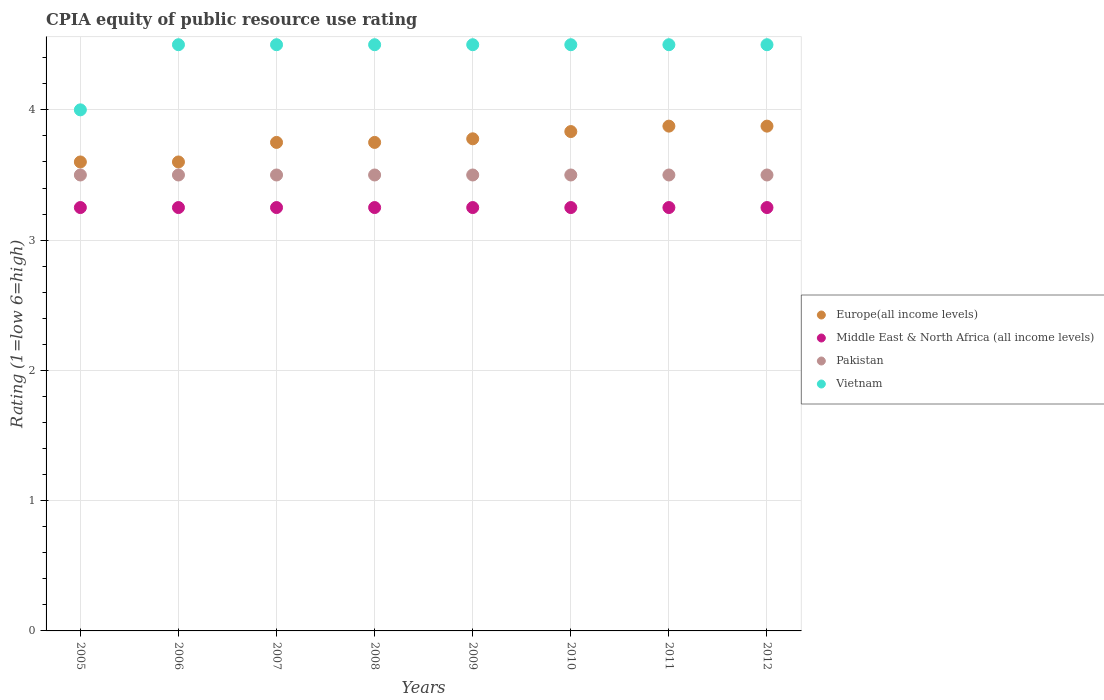How many different coloured dotlines are there?
Offer a very short reply. 4. Across all years, what is the maximum CPIA rating in Europe(all income levels)?
Keep it short and to the point. 3.88. What is the total CPIA rating in Middle East & North Africa (all income levels) in the graph?
Your answer should be compact. 26. What is the difference between the CPIA rating in Europe(all income levels) in 2006 and the CPIA rating in Middle East & North Africa (all income levels) in 2010?
Provide a short and direct response. 0.35. In the year 2012, what is the difference between the CPIA rating in Middle East & North Africa (all income levels) and CPIA rating in Vietnam?
Your answer should be very brief. -1.25. In how many years, is the CPIA rating in Europe(all income levels) greater than 1?
Your answer should be very brief. 8. Is the difference between the CPIA rating in Middle East & North Africa (all income levels) in 2006 and 2012 greater than the difference between the CPIA rating in Vietnam in 2006 and 2012?
Make the answer very short. No. What is the difference between the highest and the lowest CPIA rating in Pakistan?
Ensure brevity in your answer.  0. Is it the case that in every year, the sum of the CPIA rating in Middle East & North Africa (all income levels) and CPIA rating in Europe(all income levels)  is greater than the sum of CPIA rating in Pakistan and CPIA rating in Vietnam?
Offer a terse response. No. Is it the case that in every year, the sum of the CPIA rating in Europe(all income levels) and CPIA rating in Vietnam  is greater than the CPIA rating in Pakistan?
Offer a very short reply. Yes. Does the CPIA rating in Middle East & North Africa (all income levels) monotonically increase over the years?
Ensure brevity in your answer.  No. Is the CPIA rating in Europe(all income levels) strictly less than the CPIA rating in Middle East & North Africa (all income levels) over the years?
Give a very brief answer. No. How many dotlines are there?
Your answer should be compact. 4. Where does the legend appear in the graph?
Your answer should be compact. Center right. How are the legend labels stacked?
Offer a terse response. Vertical. What is the title of the graph?
Your response must be concise. CPIA equity of public resource use rating. What is the label or title of the X-axis?
Offer a terse response. Years. What is the label or title of the Y-axis?
Give a very brief answer. Rating (1=low 6=high). What is the Rating (1=low 6=high) in Europe(all income levels) in 2005?
Make the answer very short. 3.6. What is the Rating (1=low 6=high) of Pakistan in 2005?
Ensure brevity in your answer.  3.5. What is the Rating (1=low 6=high) of Europe(all income levels) in 2006?
Your response must be concise. 3.6. What is the Rating (1=low 6=high) of Middle East & North Africa (all income levels) in 2006?
Your answer should be compact. 3.25. What is the Rating (1=low 6=high) of Vietnam in 2006?
Make the answer very short. 4.5. What is the Rating (1=low 6=high) of Europe(all income levels) in 2007?
Provide a short and direct response. 3.75. What is the Rating (1=low 6=high) in Middle East & North Africa (all income levels) in 2007?
Your response must be concise. 3.25. What is the Rating (1=low 6=high) of Pakistan in 2007?
Make the answer very short. 3.5. What is the Rating (1=low 6=high) in Europe(all income levels) in 2008?
Your response must be concise. 3.75. What is the Rating (1=low 6=high) of Vietnam in 2008?
Make the answer very short. 4.5. What is the Rating (1=low 6=high) of Europe(all income levels) in 2009?
Your response must be concise. 3.78. What is the Rating (1=low 6=high) in Middle East & North Africa (all income levels) in 2009?
Give a very brief answer. 3.25. What is the Rating (1=low 6=high) in Europe(all income levels) in 2010?
Make the answer very short. 3.83. What is the Rating (1=low 6=high) of Middle East & North Africa (all income levels) in 2010?
Your response must be concise. 3.25. What is the Rating (1=low 6=high) of Pakistan in 2010?
Your answer should be very brief. 3.5. What is the Rating (1=low 6=high) of Europe(all income levels) in 2011?
Give a very brief answer. 3.88. What is the Rating (1=low 6=high) in Middle East & North Africa (all income levels) in 2011?
Keep it short and to the point. 3.25. What is the Rating (1=low 6=high) in Pakistan in 2011?
Your answer should be compact. 3.5. What is the Rating (1=low 6=high) in Europe(all income levels) in 2012?
Give a very brief answer. 3.88. Across all years, what is the maximum Rating (1=low 6=high) of Europe(all income levels)?
Your response must be concise. 3.88. Across all years, what is the maximum Rating (1=low 6=high) in Middle East & North Africa (all income levels)?
Your answer should be compact. 3.25. Across all years, what is the minimum Rating (1=low 6=high) in Europe(all income levels)?
Ensure brevity in your answer.  3.6. Across all years, what is the minimum Rating (1=low 6=high) in Middle East & North Africa (all income levels)?
Offer a terse response. 3.25. What is the total Rating (1=low 6=high) of Europe(all income levels) in the graph?
Give a very brief answer. 30.06. What is the total Rating (1=low 6=high) of Middle East & North Africa (all income levels) in the graph?
Offer a terse response. 26. What is the total Rating (1=low 6=high) of Vietnam in the graph?
Offer a very short reply. 35.5. What is the difference between the Rating (1=low 6=high) in Europe(all income levels) in 2005 and that in 2006?
Offer a terse response. 0. What is the difference between the Rating (1=low 6=high) in Middle East & North Africa (all income levels) in 2005 and that in 2006?
Offer a terse response. 0. What is the difference between the Rating (1=low 6=high) in Vietnam in 2005 and that in 2006?
Ensure brevity in your answer.  -0.5. What is the difference between the Rating (1=low 6=high) in Europe(all income levels) in 2005 and that in 2007?
Offer a terse response. -0.15. What is the difference between the Rating (1=low 6=high) in Vietnam in 2005 and that in 2007?
Your response must be concise. -0.5. What is the difference between the Rating (1=low 6=high) in Europe(all income levels) in 2005 and that in 2008?
Provide a succinct answer. -0.15. What is the difference between the Rating (1=low 6=high) in Middle East & North Africa (all income levels) in 2005 and that in 2008?
Provide a succinct answer. 0. What is the difference between the Rating (1=low 6=high) in Vietnam in 2005 and that in 2008?
Provide a succinct answer. -0.5. What is the difference between the Rating (1=low 6=high) of Europe(all income levels) in 2005 and that in 2009?
Your response must be concise. -0.18. What is the difference between the Rating (1=low 6=high) in Vietnam in 2005 and that in 2009?
Offer a terse response. -0.5. What is the difference between the Rating (1=low 6=high) in Europe(all income levels) in 2005 and that in 2010?
Offer a very short reply. -0.23. What is the difference between the Rating (1=low 6=high) in Middle East & North Africa (all income levels) in 2005 and that in 2010?
Provide a succinct answer. 0. What is the difference between the Rating (1=low 6=high) in Vietnam in 2005 and that in 2010?
Your answer should be compact. -0.5. What is the difference between the Rating (1=low 6=high) of Europe(all income levels) in 2005 and that in 2011?
Make the answer very short. -0.28. What is the difference between the Rating (1=low 6=high) of Middle East & North Africa (all income levels) in 2005 and that in 2011?
Offer a very short reply. 0. What is the difference between the Rating (1=low 6=high) of Europe(all income levels) in 2005 and that in 2012?
Provide a succinct answer. -0.28. What is the difference between the Rating (1=low 6=high) in Middle East & North Africa (all income levels) in 2005 and that in 2012?
Give a very brief answer. 0. What is the difference between the Rating (1=low 6=high) of Pakistan in 2005 and that in 2012?
Make the answer very short. 0. What is the difference between the Rating (1=low 6=high) of Vietnam in 2005 and that in 2012?
Provide a short and direct response. -0.5. What is the difference between the Rating (1=low 6=high) of Middle East & North Africa (all income levels) in 2006 and that in 2007?
Your answer should be very brief. 0. What is the difference between the Rating (1=low 6=high) of Europe(all income levels) in 2006 and that in 2008?
Your answer should be compact. -0.15. What is the difference between the Rating (1=low 6=high) in Middle East & North Africa (all income levels) in 2006 and that in 2008?
Provide a succinct answer. 0. What is the difference between the Rating (1=low 6=high) in Pakistan in 2006 and that in 2008?
Provide a short and direct response. 0. What is the difference between the Rating (1=low 6=high) in Europe(all income levels) in 2006 and that in 2009?
Your answer should be very brief. -0.18. What is the difference between the Rating (1=low 6=high) of Pakistan in 2006 and that in 2009?
Offer a terse response. 0. What is the difference between the Rating (1=low 6=high) of Vietnam in 2006 and that in 2009?
Offer a terse response. 0. What is the difference between the Rating (1=low 6=high) in Europe(all income levels) in 2006 and that in 2010?
Keep it short and to the point. -0.23. What is the difference between the Rating (1=low 6=high) of Pakistan in 2006 and that in 2010?
Offer a very short reply. 0. What is the difference between the Rating (1=low 6=high) in Vietnam in 2006 and that in 2010?
Make the answer very short. 0. What is the difference between the Rating (1=low 6=high) in Europe(all income levels) in 2006 and that in 2011?
Give a very brief answer. -0.28. What is the difference between the Rating (1=low 6=high) in Middle East & North Africa (all income levels) in 2006 and that in 2011?
Provide a short and direct response. 0. What is the difference between the Rating (1=low 6=high) of Pakistan in 2006 and that in 2011?
Make the answer very short. 0. What is the difference between the Rating (1=low 6=high) in Europe(all income levels) in 2006 and that in 2012?
Your answer should be very brief. -0.28. What is the difference between the Rating (1=low 6=high) in Europe(all income levels) in 2007 and that in 2008?
Your answer should be very brief. 0. What is the difference between the Rating (1=low 6=high) of Middle East & North Africa (all income levels) in 2007 and that in 2008?
Ensure brevity in your answer.  0. What is the difference between the Rating (1=low 6=high) in Vietnam in 2007 and that in 2008?
Provide a succinct answer. 0. What is the difference between the Rating (1=low 6=high) in Europe(all income levels) in 2007 and that in 2009?
Your response must be concise. -0.03. What is the difference between the Rating (1=low 6=high) in Middle East & North Africa (all income levels) in 2007 and that in 2009?
Give a very brief answer. 0. What is the difference between the Rating (1=low 6=high) of Pakistan in 2007 and that in 2009?
Ensure brevity in your answer.  0. What is the difference between the Rating (1=low 6=high) of Europe(all income levels) in 2007 and that in 2010?
Your response must be concise. -0.08. What is the difference between the Rating (1=low 6=high) in Pakistan in 2007 and that in 2010?
Your response must be concise. 0. What is the difference between the Rating (1=low 6=high) of Vietnam in 2007 and that in 2010?
Provide a succinct answer. 0. What is the difference between the Rating (1=low 6=high) in Europe(all income levels) in 2007 and that in 2011?
Make the answer very short. -0.12. What is the difference between the Rating (1=low 6=high) of Vietnam in 2007 and that in 2011?
Your answer should be very brief. 0. What is the difference between the Rating (1=low 6=high) of Europe(all income levels) in 2007 and that in 2012?
Your response must be concise. -0.12. What is the difference between the Rating (1=low 6=high) in Vietnam in 2007 and that in 2012?
Your answer should be very brief. 0. What is the difference between the Rating (1=low 6=high) in Europe(all income levels) in 2008 and that in 2009?
Provide a succinct answer. -0.03. What is the difference between the Rating (1=low 6=high) in Middle East & North Africa (all income levels) in 2008 and that in 2009?
Your answer should be very brief. 0. What is the difference between the Rating (1=low 6=high) of Europe(all income levels) in 2008 and that in 2010?
Your response must be concise. -0.08. What is the difference between the Rating (1=low 6=high) of Europe(all income levels) in 2008 and that in 2011?
Provide a succinct answer. -0.12. What is the difference between the Rating (1=low 6=high) of Middle East & North Africa (all income levels) in 2008 and that in 2011?
Provide a succinct answer. 0. What is the difference between the Rating (1=low 6=high) in Vietnam in 2008 and that in 2011?
Provide a short and direct response. 0. What is the difference between the Rating (1=low 6=high) in Europe(all income levels) in 2008 and that in 2012?
Ensure brevity in your answer.  -0.12. What is the difference between the Rating (1=low 6=high) in Europe(all income levels) in 2009 and that in 2010?
Your response must be concise. -0.06. What is the difference between the Rating (1=low 6=high) in Middle East & North Africa (all income levels) in 2009 and that in 2010?
Offer a terse response. 0. What is the difference between the Rating (1=low 6=high) of Vietnam in 2009 and that in 2010?
Offer a very short reply. 0. What is the difference between the Rating (1=low 6=high) in Europe(all income levels) in 2009 and that in 2011?
Make the answer very short. -0.1. What is the difference between the Rating (1=low 6=high) in Middle East & North Africa (all income levels) in 2009 and that in 2011?
Ensure brevity in your answer.  0. What is the difference between the Rating (1=low 6=high) of Pakistan in 2009 and that in 2011?
Give a very brief answer. 0. What is the difference between the Rating (1=low 6=high) of Vietnam in 2009 and that in 2011?
Keep it short and to the point. 0. What is the difference between the Rating (1=low 6=high) in Europe(all income levels) in 2009 and that in 2012?
Provide a succinct answer. -0.1. What is the difference between the Rating (1=low 6=high) in Middle East & North Africa (all income levels) in 2009 and that in 2012?
Your response must be concise. 0. What is the difference between the Rating (1=low 6=high) of Pakistan in 2009 and that in 2012?
Your answer should be very brief. 0. What is the difference between the Rating (1=low 6=high) of Europe(all income levels) in 2010 and that in 2011?
Provide a succinct answer. -0.04. What is the difference between the Rating (1=low 6=high) in Middle East & North Africa (all income levels) in 2010 and that in 2011?
Give a very brief answer. 0. What is the difference between the Rating (1=low 6=high) in Europe(all income levels) in 2010 and that in 2012?
Your response must be concise. -0.04. What is the difference between the Rating (1=low 6=high) of Middle East & North Africa (all income levels) in 2010 and that in 2012?
Make the answer very short. 0. What is the difference between the Rating (1=low 6=high) in Pakistan in 2010 and that in 2012?
Provide a short and direct response. 0. What is the difference between the Rating (1=low 6=high) in Vietnam in 2010 and that in 2012?
Your answer should be very brief. 0. What is the difference between the Rating (1=low 6=high) in Vietnam in 2011 and that in 2012?
Give a very brief answer. 0. What is the difference between the Rating (1=low 6=high) in Europe(all income levels) in 2005 and the Rating (1=low 6=high) in Vietnam in 2006?
Your response must be concise. -0.9. What is the difference between the Rating (1=low 6=high) in Middle East & North Africa (all income levels) in 2005 and the Rating (1=low 6=high) in Vietnam in 2006?
Keep it short and to the point. -1.25. What is the difference between the Rating (1=low 6=high) in Pakistan in 2005 and the Rating (1=low 6=high) in Vietnam in 2006?
Your answer should be very brief. -1. What is the difference between the Rating (1=low 6=high) in Europe(all income levels) in 2005 and the Rating (1=low 6=high) in Middle East & North Africa (all income levels) in 2007?
Ensure brevity in your answer.  0.35. What is the difference between the Rating (1=low 6=high) in Europe(all income levels) in 2005 and the Rating (1=low 6=high) in Pakistan in 2007?
Your answer should be compact. 0.1. What is the difference between the Rating (1=low 6=high) of Middle East & North Africa (all income levels) in 2005 and the Rating (1=low 6=high) of Vietnam in 2007?
Make the answer very short. -1.25. What is the difference between the Rating (1=low 6=high) in Europe(all income levels) in 2005 and the Rating (1=low 6=high) in Vietnam in 2008?
Offer a terse response. -0.9. What is the difference between the Rating (1=low 6=high) of Middle East & North Africa (all income levels) in 2005 and the Rating (1=low 6=high) of Vietnam in 2008?
Your answer should be very brief. -1.25. What is the difference between the Rating (1=low 6=high) of Europe(all income levels) in 2005 and the Rating (1=low 6=high) of Middle East & North Africa (all income levels) in 2009?
Make the answer very short. 0.35. What is the difference between the Rating (1=low 6=high) in Europe(all income levels) in 2005 and the Rating (1=low 6=high) in Pakistan in 2009?
Offer a terse response. 0.1. What is the difference between the Rating (1=low 6=high) of Europe(all income levels) in 2005 and the Rating (1=low 6=high) of Vietnam in 2009?
Offer a terse response. -0.9. What is the difference between the Rating (1=low 6=high) of Middle East & North Africa (all income levels) in 2005 and the Rating (1=low 6=high) of Vietnam in 2009?
Give a very brief answer. -1.25. What is the difference between the Rating (1=low 6=high) in Europe(all income levels) in 2005 and the Rating (1=low 6=high) in Middle East & North Africa (all income levels) in 2010?
Make the answer very short. 0.35. What is the difference between the Rating (1=low 6=high) of Europe(all income levels) in 2005 and the Rating (1=low 6=high) of Pakistan in 2010?
Offer a very short reply. 0.1. What is the difference between the Rating (1=low 6=high) in Europe(all income levels) in 2005 and the Rating (1=low 6=high) in Vietnam in 2010?
Ensure brevity in your answer.  -0.9. What is the difference between the Rating (1=low 6=high) in Middle East & North Africa (all income levels) in 2005 and the Rating (1=low 6=high) in Vietnam in 2010?
Your answer should be compact. -1.25. What is the difference between the Rating (1=low 6=high) of Pakistan in 2005 and the Rating (1=low 6=high) of Vietnam in 2010?
Your response must be concise. -1. What is the difference between the Rating (1=low 6=high) in Europe(all income levels) in 2005 and the Rating (1=low 6=high) in Middle East & North Africa (all income levels) in 2011?
Keep it short and to the point. 0.35. What is the difference between the Rating (1=low 6=high) in Europe(all income levels) in 2005 and the Rating (1=low 6=high) in Pakistan in 2011?
Provide a succinct answer. 0.1. What is the difference between the Rating (1=low 6=high) in Middle East & North Africa (all income levels) in 2005 and the Rating (1=low 6=high) in Vietnam in 2011?
Keep it short and to the point. -1.25. What is the difference between the Rating (1=low 6=high) of Europe(all income levels) in 2005 and the Rating (1=low 6=high) of Middle East & North Africa (all income levels) in 2012?
Provide a short and direct response. 0.35. What is the difference between the Rating (1=low 6=high) of Europe(all income levels) in 2005 and the Rating (1=low 6=high) of Vietnam in 2012?
Your answer should be compact. -0.9. What is the difference between the Rating (1=low 6=high) in Middle East & North Africa (all income levels) in 2005 and the Rating (1=low 6=high) in Vietnam in 2012?
Your answer should be very brief. -1.25. What is the difference between the Rating (1=low 6=high) in Pakistan in 2005 and the Rating (1=low 6=high) in Vietnam in 2012?
Provide a short and direct response. -1. What is the difference between the Rating (1=low 6=high) in Europe(all income levels) in 2006 and the Rating (1=low 6=high) in Middle East & North Africa (all income levels) in 2007?
Provide a short and direct response. 0.35. What is the difference between the Rating (1=low 6=high) in Europe(all income levels) in 2006 and the Rating (1=low 6=high) in Vietnam in 2007?
Keep it short and to the point. -0.9. What is the difference between the Rating (1=low 6=high) in Middle East & North Africa (all income levels) in 2006 and the Rating (1=low 6=high) in Vietnam in 2007?
Your answer should be compact. -1.25. What is the difference between the Rating (1=low 6=high) of Europe(all income levels) in 2006 and the Rating (1=low 6=high) of Middle East & North Africa (all income levels) in 2008?
Provide a succinct answer. 0.35. What is the difference between the Rating (1=low 6=high) in Europe(all income levels) in 2006 and the Rating (1=low 6=high) in Vietnam in 2008?
Make the answer very short. -0.9. What is the difference between the Rating (1=low 6=high) of Middle East & North Africa (all income levels) in 2006 and the Rating (1=low 6=high) of Vietnam in 2008?
Your answer should be compact. -1.25. What is the difference between the Rating (1=low 6=high) in Europe(all income levels) in 2006 and the Rating (1=low 6=high) in Middle East & North Africa (all income levels) in 2009?
Your answer should be compact. 0.35. What is the difference between the Rating (1=low 6=high) of Europe(all income levels) in 2006 and the Rating (1=low 6=high) of Pakistan in 2009?
Offer a terse response. 0.1. What is the difference between the Rating (1=low 6=high) of Middle East & North Africa (all income levels) in 2006 and the Rating (1=low 6=high) of Vietnam in 2009?
Your answer should be very brief. -1.25. What is the difference between the Rating (1=low 6=high) in Europe(all income levels) in 2006 and the Rating (1=low 6=high) in Middle East & North Africa (all income levels) in 2010?
Offer a terse response. 0.35. What is the difference between the Rating (1=low 6=high) of Europe(all income levels) in 2006 and the Rating (1=low 6=high) of Vietnam in 2010?
Your answer should be compact. -0.9. What is the difference between the Rating (1=low 6=high) of Middle East & North Africa (all income levels) in 2006 and the Rating (1=low 6=high) of Vietnam in 2010?
Give a very brief answer. -1.25. What is the difference between the Rating (1=low 6=high) of Europe(all income levels) in 2006 and the Rating (1=low 6=high) of Pakistan in 2011?
Your response must be concise. 0.1. What is the difference between the Rating (1=low 6=high) of Europe(all income levels) in 2006 and the Rating (1=low 6=high) of Vietnam in 2011?
Provide a succinct answer. -0.9. What is the difference between the Rating (1=low 6=high) of Middle East & North Africa (all income levels) in 2006 and the Rating (1=low 6=high) of Pakistan in 2011?
Your answer should be compact. -0.25. What is the difference between the Rating (1=low 6=high) in Middle East & North Africa (all income levels) in 2006 and the Rating (1=low 6=high) in Vietnam in 2011?
Keep it short and to the point. -1.25. What is the difference between the Rating (1=low 6=high) in Pakistan in 2006 and the Rating (1=low 6=high) in Vietnam in 2011?
Your answer should be compact. -1. What is the difference between the Rating (1=low 6=high) of Europe(all income levels) in 2006 and the Rating (1=low 6=high) of Pakistan in 2012?
Give a very brief answer. 0.1. What is the difference between the Rating (1=low 6=high) in Europe(all income levels) in 2006 and the Rating (1=low 6=high) in Vietnam in 2012?
Offer a terse response. -0.9. What is the difference between the Rating (1=low 6=high) of Middle East & North Africa (all income levels) in 2006 and the Rating (1=low 6=high) of Pakistan in 2012?
Your answer should be very brief. -0.25. What is the difference between the Rating (1=low 6=high) of Middle East & North Africa (all income levels) in 2006 and the Rating (1=low 6=high) of Vietnam in 2012?
Provide a short and direct response. -1.25. What is the difference between the Rating (1=low 6=high) of Europe(all income levels) in 2007 and the Rating (1=low 6=high) of Vietnam in 2008?
Offer a very short reply. -0.75. What is the difference between the Rating (1=low 6=high) of Middle East & North Africa (all income levels) in 2007 and the Rating (1=low 6=high) of Pakistan in 2008?
Give a very brief answer. -0.25. What is the difference between the Rating (1=low 6=high) in Middle East & North Africa (all income levels) in 2007 and the Rating (1=low 6=high) in Vietnam in 2008?
Keep it short and to the point. -1.25. What is the difference between the Rating (1=low 6=high) in Europe(all income levels) in 2007 and the Rating (1=low 6=high) in Vietnam in 2009?
Make the answer very short. -0.75. What is the difference between the Rating (1=low 6=high) in Middle East & North Africa (all income levels) in 2007 and the Rating (1=low 6=high) in Pakistan in 2009?
Your response must be concise. -0.25. What is the difference between the Rating (1=low 6=high) of Middle East & North Africa (all income levels) in 2007 and the Rating (1=low 6=high) of Vietnam in 2009?
Your answer should be very brief. -1.25. What is the difference between the Rating (1=low 6=high) in Europe(all income levels) in 2007 and the Rating (1=low 6=high) in Middle East & North Africa (all income levels) in 2010?
Provide a short and direct response. 0.5. What is the difference between the Rating (1=low 6=high) in Europe(all income levels) in 2007 and the Rating (1=low 6=high) in Vietnam in 2010?
Make the answer very short. -0.75. What is the difference between the Rating (1=low 6=high) of Middle East & North Africa (all income levels) in 2007 and the Rating (1=low 6=high) of Pakistan in 2010?
Your answer should be very brief. -0.25. What is the difference between the Rating (1=low 6=high) in Middle East & North Africa (all income levels) in 2007 and the Rating (1=low 6=high) in Vietnam in 2010?
Provide a succinct answer. -1.25. What is the difference between the Rating (1=low 6=high) of Europe(all income levels) in 2007 and the Rating (1=low 6=high) of Pakistan in 2011?
Provide a succinct answer. 0.25. What is the difference between the Rating (1=low 6=high) in Europe(all income levels) in 2007 and the Rating (1=low 6=high) in Vietnam in 2011?
Make the answer very short. -0.75. What is the difference between the Rating (1=low 6=high) of Middle East & North Africa (all income levels) in 2007 and the Rating (1=low 6=high) of Pakistan in 2011?
Your answer should be compact. -0.25. What is the difference between the Rating (1=low 6=high) of Middle East & North Africa (all income levels) in 2007 and the Rating (1=low 6=high) of Vietnam in 2011?
Your answer should be compact. -1.25. What is the difference between the Rating (1=low 6=high) in Europe(all income levels) in 2007 and the Rating (1=low 6=high) in Pakistan in 2012?
Your response must be concise. 0.25. What is the difference between the Rating (1=low 6=high) of Europe(all income levels) in 2007 and the Rating (1=low 6=high) of Vietnam in 2012?
Provide a short and direct response. -0.75. What is the difference between the Rating (1=low 6=high) in Middle East & North Africa (all income levels) in 2007 and the Rating (1=low 6=high) in Vietnam in 2012?
Keep it short and to the point. -1.25. What is the difference between the Rating (1=low 6=high) in Europe(all income levels) in 2008 and the Rating (1=low 6=high) in Vietnam in 2009?
Make the answer very short. -0.75. What is the difference between the Rating (1=low 6=high) in Middle East & North Africa (all income levels) in 2008 and the Rating (1=low 6=high) in Vietnam in 2009?
Your response must be concise. -1.25. What is the difference between the Rating (1=low 6=high) in Pakistan in 2008 and the Rating (1=low 6=high) in Vietnam in 2009?
Provide a short and direct response. -1. What is the difference between the Rating (1=low 6=high) in Europe(all income levels) in 2008 and the Rating (1=low 6=high) in Middle East & North Africa (all income levels) in 2010?
Your answer should be very brief. 0.5. What is the difference between the Rating (1=low 6=high) of Europe(all income levels) in 2008 and the Rating (1=low 6=high) of Vietnam in 2010?
Provide a succinct answer. -0.75. What is the difference between the Rating (1=low 6=high) of Middle East & North Africa (all income levels) in 2008 and the Rating (1=low 6=high) of Vietnam in 2010?
Offer a terse response. -1.25. What is the difference between the Rating (1=low 6=high) in Pakistan in 2008 and the Rating (1=low 6=high) in Vietnam in 2010?
Offer a terse response. -1. What is the difference between the Rating (1=low 6=high) in Europe(all income levels) in 2008 and the Rating (1=low 6=high) in Middle East & North Africa (all income levels) in 2011?
Provide a short and direct response. 0.5. What is the difference between the Rating (1=low 6=high) in Europe(all income levels) in 2008 and the Rating (1=low 6=high) in Pakistan in 2011?
Offer a terse response. 0.25. What is the difference between the Rating (1=low 6=high) in Europe(all income levels) in 2008 and the Rating (1=low 6=high) in Vietnam in 2011?
Ensure brevity in your answer.  -0.75. What is the difference between the Rating (1=low 6=high) of Middle East & North Africa (all income levels) in 2008 and the Rating (1=low 6=high) of Pakistan in 2011?
Provide a succinct answer. -0.25. What is the difference between the Rating (1=low 6=high) in Middle East & North Africa (all income levels) in 2008 and the Rating (1=low 6=high) in Vietnam in 2011?
Make the answer very short. -1.25. What is the difference between the Rating (1=low 6=high) of Europe(all income levels) in 2008 and the Rating (1=low 6=high) of Vietnam in 2012?
Keep it short and to the point. -0.75. What is the difference between the Rating (1=low 6=high) of Middle East & North Africa (all income levels) in 2008 and the Rating (1=low 6=high) of Vietnam in 2012?
Give a very brief answer. -1.25. What is the difference between the Rating (1=low 6=high) in Europe(all income levels) in 2009 and the Rating (1=low 6=high) in Middle East & North Africa (all income levels) in 2010?
Ensure brevity in your answer.  0.53. What is the difference between the Rating (1=low 6=high) of Europe(all income levels) in 2009 and the Rating (1=low 6=high) of Pakistan in 2010?
Your answer should be compact. 0.28. What is the difference between the Rating (1=low 6=high) in Europe(all income levels) in 2009 and the Rating (1=low 6=high) in Vietnam in 2010?
Ensure brevity in your answer.  -0.72. What is the difference between the Rating (1=low 6=high) of Middle East & North Africa (all income levels) in 2009 and the Rating (1=low 6=high) of Vietnam in 2010?
Provide a short and direct response. -1.25. What is the difference between the Rating (1=low 6=high) of Pakistan in 2009 and the Rating (1=low 6=high) of Vietnam in 2010?
Provide a succinct answer. -1. What is the difference between the Rating (1=low 6=high) of Europe(all income levels) in 2009 and the Rating (1=low 6=high) of Middle East & North Africa (all income levels) in 2011?
Offer a very short reply. 0.53. What is the difference between the Rating (1=low 6=high) in Europe(all income levels) in 2009 and the Rating (1=low 6=high) in Pakistan in 2011?
Offer a very short reply. 0.28. What is the difference between the Rating (1=low 6=high) of Europe(all income levels) in 2009 and the Rating (1=low 6=high) of Vietnam in 2011?
Your response must be concise. -0.72. What is the difference between the Rating (1=low 6=high) in Middle East & North Africa (all income levels) in 2009 and the Rating (1=low 6=high) in Vietnam in 2011?
Give a very brief answer. -1.25. What is the difference between the Rating (1=low 6=high) in Europe(all income levels) in 2009 and the Rating (1=low 6=high) in Middle East & North Africa (all income levels) in 2012?
Keep it short and to the point. 0.53. What is the difference between the Rating (1=low 6=high) of Europe(all income levels) in 2009 and the Rating (1=low 6=high) of Pakistan in 2012?
Make the answer very short. 0.28. What is the difference between the Rating (1=low 6=high) in Europe(all income levels) in 2009 and the Rating (1=low 6=high) in Vietnam in 2012?
Ensure brevity in your answer.  -0.72. What is the difference between the Rating (1=low 6=high) in Middle East & North Africa (all income levels) in 2009 and the Rating (1=low 6=high) in Pakistan in 2012?
Provide a succinct answer. -0.25. What is the difference between the Rating (1=low 6=high) of Middle East & North Africa (all income levels) in 2009 and the Rating (1=low 6=high) of Vietnam in 2012?
Provide a succinct answer. -1.25. What is the difference between the Rating (1=low 6=high) of Pakistan in 2009 and the Rating (1=low 6=high) of Vietnam in 2012?
Ensure brevity in your answer.  -1. What is the difference between the Rating (1=low 6=high) of Europe(all income levels) in 2010 and the Rating (1=low 6=high) of Middle East & North Africa (all income levels) in 2011?
Your answer should be compact. 0.58. What is the difference between the Rating (1=low 6=high) in Europe(all income levels) in 2010 and the Rating (1=low 6=high) in Vietnam in 2011?
Your answer should be compact. -0.67. What is the difference between the Rating (1=low 6=high) of Middle East & North Africa (all income levels) in 2010 and the Rating (1=low 6=high) of Vietnam in 2011?
Your answer should be very brief. -1.25. What is the difference between the Rating (1=low 6=high) of Europe(all income levels) in 2010 and the Rating (1=low 6=high) of Middle East & North Africa (all income levels) in 2012?
Your answer should be very brief. 0.58. What is the difference between the Rating (1=low 6=high) of Europe(all income levels) in 2010 and the Rating (1=low 6=high) of Pakistan in 2012?
Ensure brevity in your answer.  0.33. What is the difference between the Rating (1=low 6=high) of Europe(all income levels) in 2010 and the Rating (1=low 6=high) of Vietnam in 2012?
Your response must be concise. -0.67. What is the difference between the Rating (1=low 6=high) of Middle East & North Africa (all income levels) in 2010 and the Rating (1=low 6=high) of Pakistan in 2012?
Provide a short and direct response. -0.25. What is the difference between the Rating (1=low 6=high) of Middle East & North Africa (all income levels) in 2010 and the Rating (1=low 6=high) of Vietnam in 2012?
Your answer should be compact. -1.25. What is the difference between the Rating (1=low 6=high) of Europe(all income levels) in 2011 and the Rating (1=low 6=high) of Middle East & North Africa (all income levels) in 2012?
Give a very brief answer. 0.62. What is the difference between the Rating (1=low 6=high) of Europe(all income levels) in 2011 and the Rating (1=low 6=high) of Pakistan in 2012?
Give a very brief answer. 0.38. What is the difference between the Rating (1=low 6=high) of Europe(all income levels) in 2011 and the Rating (1=low 6=high) of Vietnam in 2012?
Your answer should be compact. -0.62. What is the difference between the Rating (1=low 6=high) of Middle East & North Africa (all income levels) in 2011 and the Rating (1=low 6=high) of Pakistan in 2012?
Keep it short and to the point. -0.25. What is the difference between the Rating (1=low 6=high) in Middle East & North Africa (all income levels) in 2011 and the Rating (1=low 6=high) in Vietnam in 2012?
Keep it short and to the point. -1.25. What is the average Rating (1=low 6=high) in Europe(all income levels) per year?
Your answer should be compact. 3.76. What is the average Rating (1=low 6=high) in Pakistan per year?
Give a very brief answer. 3.5. What is the average Rating (1=low 6=high) of Vietnam per year?
Your answer should be very brief. 4.44. In the year 2005, what is the difference between the Rating (1=low 6=high) of Europe(all income levels) and Rating (1=low 6=high) of Vietnam?
Provide a short and direct response. -0.4. In the year 2005, what is the difference between the Rating (1=low 6=high) of Middle East & North Africa (all income levels) and Rating (1=low 6=high) of Vietnam?
Your answer should be very brief. -0.75. In the year 2005, what is the difference between the Rating (1=low 6=high) of Pakistan and Rating (1=low 6=high) of Vietnam?
Your response must be concise. -0.5. In the year 2006, what is the difference between the Rating (1=low 6=high) of Europe(all income levels) and Rating (1=low 6=high) of Vietnam?
Give a very brief answer. -0.9. In the year 2006, what is the difference between the Rating (1=low 6=high) in Middle East & North Africa (all income levels) and Rating (1=low 6=high) in Pakistan?
Provide a succinct answer. -0.25. In the year 2006, what is the difference between the Rating (1=low 6=high) in Middle East & North Africa (all income levels) and Rating (1=low 6=high) in Vietnam?
Your answer should be very brief. -1.25. In the year 2007, what is the difference between the Rating (1=low 6=high) of Europe(all income levels) and Rating (1=low 6=high) of Middle East & North Africa (all income levels)?
Make the answer very short. 0.5. In the year 2007, what is the difference between the Rating (1=low 6=high) of Europe(all income levels) and Rating (1=low 6=high) of Pakistan?
Provide a short and direct response. 0.25. In the year 2007, what is the difference between the Rating (1=low 6=high) of Europe(all income levels) and Rating (1=low 6=high) of Vietnam?
Ensure brevity in your answer.  -0.75. In the year 2007, what is the difference between the Rating (1=low 6=high) of Middle East & North Africa (all income levels) and Rating (1=low 6=high) of Vietnam?
Make the answer very short. -1.25. In the year 2008, what is the difference between the Rating (1=low 6=high) of Europe(all income levels) and Rating (1=low 6=high) of Pakistan?
Give a very brief answer. 0.25. In the year 2008, what is the difference between the Rating (1=low 6=high) in Europe(all income levels) and Rating (1=low 6=high) in Vietnam?
Make the answer very short. -0.75. In the year 2008, what is the difference between the Rating (1=low 6=high) of Middle East & North Africa (all income levels) and Rating (1=low 6=high) of Vietnam?
Provide a short and direct response. -1.25. In the year 2009, what is the difference between the Rating (1=low 6=high) in Europe(all income levels) and Rating (1=low 6=high) in Middle East & North Africa (all income levels)?
Keep it short and to the point. 0.53. In the year 2009, what is the difference between the Rating (1=low 6=high) in Europe(all income levels) and Rating (1=low 6=high) in Pakistan?
Offer a terse response. 0.28. In the year 2009, what is the difference between the Rating (1=low 6=high) of Europe(all income levels) and Rating (1=low 6=high) of Vietnam?
Make the answer very short. -0.72. In the year 2009, what is the difference between the Rating (1=low 6=high) of Middle East & North Africa (all income levels) and Rating (1=low 6=high) of Vietnam?
Offer a very short reply. -1.25. In the year 2010, what is the difference between the Rating (1=low 6=high) of Europe(all income levels) and Rating (1=low 6=high) of Middle East & North Africa (all income levels)?
Offer a terse response. 0.58. In the year 2010, what is the difference between the Rating (1=low 6=high) in Europe(all income levels) and Rating (1=low 6=high) in Vietnam?
Your response must be concise. -0.67. In the year 2010, what is the difference between the Rating (1=low 6=high) in Middle East & North Africa (all income levels) and Rating (1=low 6=high) in Pakistan?
Provide a short and direct response. -0.25. In the year 2010, what is the difference between the Rating (1=low 6=high) in Middle East & North Africa (all income levels) and Rating (1=low 6=high) in Vietnam?
Offer a very short reply. -1.25. In the year 2010, what is the difference between the Rating (1=low 6=high) of Pakistan and Rating (1=low 6=high) of Vietnam?
Offer a very short reply. -1. In the year 2011, what is the difference between the Rating (1=low 6=high) in Europe(all income levels) and Rating (1=low 6=high) in Vietnam?
Keep it short and to the point. -0.62. In the year 2011, what is the difference between the Rating (1=low 6=high) of Middle East & North Africa (all income levels) and Rating (1=low 6=high) of Vietnam?
Your answer should be very brief. -1.25. In the year 2012, what is the difference between the Rating (1=low 6=high) in Europe(all income levels) and Rating (1=low 6=high) in Pakistan?
Provide a short and direct response. 0.38. In the year 2012, what is the difference between the Rating (1=low 6=high) in Europe(all income levels) and Rating (1=low 6=high) in Vietnam?
Your response must be concise. -0.62. In the year 2012, what is the difference between the Rating (1=low 6=high) in Middle East & North Africa (all income levels) and Rating (1=low 6=high) in Vietnam?
Provide a succinct answer. -1.25. In the year 2012, what is the difference between the Rating (1=low 6=high) of Pakistan and Rating (1=low 6=high) of Vietnam?
Ensure brevity in your answer.  -1. What is the ratio of the Rating (1=low 6=high) of Middle East & North Africa (all income levels) in 2005 to that in 2006?
Keep it short and to the point. 1. What is the ratio of the Rating (1=low 6=high) in Middle East & North Africa (all income levels) in 2005 to that in 2007?
Offer a very short reply. 1. What is the ratio of the Rating (1=low 6=high) in Europe(all income levels) in 2005 to that in 2008?
Provide a succinct answer. 0.96. What is the ratio of the Rating (1=low 6=high) of Middle East & North Africa (all income levels) in 2005 to that in 2008?
Make the answer very short. 1. What is the ratio of the Rating (1=low 6=high) in Pakistan in 2005 to that in 2008?
Offer a very short reply. 1. What is the ratio of the Rating (1=low 6=high) of Europe(all income levels) in 2005 to that in 2009?
Offer a very short reply. 0.95. What is the ratio of the Rating (1=low 6=high) in Middle East & North Africa (all income levels) in 2005 to that in 2009?
Give a very brief answer. 1. What is the ratio of the Rating (1=low 6=high) of Pakistan in 2005 to that in 2009?
Ensure brevity in your answer.  1. What is the ratio of the Rating (1=low 6=high) of Europe(all income levels) in 2005 to that in 2010?
Offer a terse response. 0.94. What is the ratio of the Rating (1=low 6=high) of Vietnam in 2005 to that in 2010?
Offer a very short reply. 0.89. What is the ratio of the Rating (1=low 6=high) of Europe(all income levels) in 2005 to that in 2011?
Keep it short and to the point. 0.93. What is the ratio of the Rating (1=low 6=high) of Pakistan in 2005 to that in 2011?
Keep it short and to the point. 1. What is the ratio of the Rating (1=low 6=high) of Europe(all income levels) in 2005 to that in 2012?
Your response must be concise. 0.93. What is the ratio of the Rating (1=low 6=high) of Vietnam in 2005 to that in 2012?
Provide a short and direct response. 0.89. What is the ratio of the Rating (1=low 6=high) of Middle East & North Africa (all income levels) in 2006 to that in 2007?
Offer a terse response. 1. What is the ratio of the Rating (1=low 6=high) in Vietnam in 2006 to that in 2008?
Offer a very short reply. 1. What is the ratio of the Rating (1=low 6=high) of Europe(all income levels) in 2006 to that in 2009?
Make the answer very short. 0.95. What is the ratio of the Rating (1=low 6=high) of Middle East & North Africa (all income levels) in 2006 to that in 2009?
Offer a very short reply. 1. What is the ratio of the Rating (1=low 6=high) in Europe(all income levels) in 2006 to that in 2010?
Provide a succinct answer. 0.94. What is the ratio of the Rating (1=low 6=high) in Pakistan in 2006 to that in 2010?
Offer a very short reply. 1. What is the ratio of the Rating (1=low 6=high) of Europe(all income levels) in 2006 to that in 2011?
Your answer should be compact. 0.93. What is the ratio of the Rating (1=low 6=high) in Pakistan in 2006 to that in 2011?
Provide a short and direct response. 1. What is the ratio of the Rating (1=low 6=high) in Europe(all income levels) in 2006 to that in 2012?
Ensure brevity in your answer.  0.93. What is the ratio of the Rating (1=low 6=high) of Middle East & North Africa (all income levels) in 2006 to that in 2012?
Provide a succinct answer. 1. What is the ratio of the Rating (1=low 6=high) in Pakistan in 2006 to that in 2012?
Your response must be concise. 1. What is the ratio of the Rating (1=low 6=high) in Vietnam in 2006 to that in 2012?
Provide a short and direct response. 1. What is the ratio of the Rating (1=low 6=high) in Middle East & North Africa (all income levels) in 2007 to that in 2008?
Ensure brevity in your answer.  1. What is the ratio of the Rating (1=low 6=high) of Vietnam in 2007 to that in 2008?
Your answer should be compact. 1. What is the ratio of the Rating (1=low 6=high) in Europe(all income levels) in 2007 to that in 2010?
Keep it short and to the point. 0.98. What is the ratio of the Rating (1=low 6=high) of Pakistan in 2007 to that in 2010?
Give a very brief answer. 1. What is the ratio of the Rating (1=low 6=high) of Europe(all income levels) in 2007 to that in 2011?
Provide a short and direct response. 0.97. What is the ratio of the Rating (1=low 6=high) of Middle East & North Africa (all income levels) in 2007 to that in 2011?
Offer a very short reply. 1. What is the ratio of the Rating (1=low 6=high) of Pakistan in 2007 to that in 2011?
Your response must be concise. 1. What is the ratio of the Rating (1=low 6=high) in Europe(all income levels) in 2007 to that in 2012?
Ensure brevity in your answer.  0.97. What is the ratio of the Rating (1=low 6=high) in Vietnam in 2007 to that in 2012?
Provide a succinct answer. 1. What is the ratio of the Rating (1=low 6=high) of Europe(all income levels) in 2008 to that in 2009?
Provide a succinct answer. 0.99. What is the ratio of the Rating (1=low 6=high) of Pakistan in 2008 to that in 2009?
Your response must be concise. 1. What is the ratio of the Rating (1=low 6=high) in Europe(all income levels) in 2008 to that in 2010?
Offer a terse response. 0.98. What is the ratio of the Rating (1=low 6=high) in Pakistan in 2008 to that in 2010?
Offer a terse response. 1. What is the ratio of the Rating (1=low 6=high) in Europe(all income levels) in 2008 to that in 2011?
Provide a short and direct response. 0.97. What is the ratio of the Rating (1=low 6=high) of Middle East & North Africa (all income levels) in 2008 to that in 2011?
Your response must be concise. 1. What is the ratio of the Rating (1=low 6=high) in Vietnam in 2008 to that in 2011?
Provide a short and direct response. 1. What is the ratio of the Rating (1=low 6=high) in Vietnam in 2008 to that in 2012?
Provide a short and direct response. 1. What is the ratio of the Rating (1=low 6=high) in Europe(all income levels) in 2009 to that in 2010?
Make the answer very short. 0.99. What is the ratio of the Rating (1=low 6=high) of Middle East & North Africa (all income levels) in 2009 to that in 2010?
Offer a very short reply. 1. What is the ratio of the Rating (1=low 6=high) of Pakistan in 2009 to that in 2010?
Your answer should be very brief. 1. What is the ratio of the Rating (1=low 6=high) of Europe(all income levels) in 2009 to that in 2011?
Your response must be concise. 0.97. What is the ratio of the Rating (1=low 6=high) in Pakistan in 2009 to that in 2011?
Your answer should be very brief. 1. What is the ratio of the Rating (1=low 6=high) of Vietnam in 2009 to that in 2011?
Make the answer very short. 1. What is the ratio of the Rating (1=low 6=high) of Europe(all income levels) in 2009 to that in 2012?
Your response must be concise. 0.97. What is the ratio of the Rating (1=low 6=high) in Middle East & North Africa (all income levels) in 2009 to that in 2012?
Make the answer very short. 1. What is the ratio of the Rating (1=low 6=high) of Pakistan in 2009 to that in 2012?
Your answer should be very brief. 1. What is the ratio of the Rating (1=low 6=high) of Middle East & North Africa (all income levels) in 2010 to that in 2011?
Provide a short and direct response. 1. What is the ratio of the Rating (1=low 6=high) in Europe(all income levels) in 2011 to that in 2012?
Your answer should be compact. 1. What is the ratio of the Rating (1=low 6=high) in Middle East & North Africa (all income levels) in 2011 to that in 2012?
Give a very brief answer. 1. What is the ratio of the Rating (1=low 6=high) of Pakistan in 2011 to that in 2012?
Keep it short and to the point. 1. What is the difference between the highest and the second highest Rating (1=low 6=high) in Europe(all income levels)?
Ensure brevity in your answer.  0. What is the difference between the highest and the second highest Rating (1=low 6=high) of Middle East & North Africa (all income levels)?
Your answer should be very brief. 0. What is the difference between the highest and the second highest Rating (1=low 6=high) of Pakistan?
Ensure brevity in your answer.  0. What is the difference between the highest and the second highest Rating (1=low 6=high) of Vietnam?
Your answer should be very brief. 0. What is the difference between the highest and the lowest Rating (1=low 6=high) in Europe(all income levels)?
Give a very brief answer. 0.28. What is the difference between the highest and the lowest Rating (1=low 6=high) of Middle East & North Africa (all income levels)?
Make the answer very short. 0. 